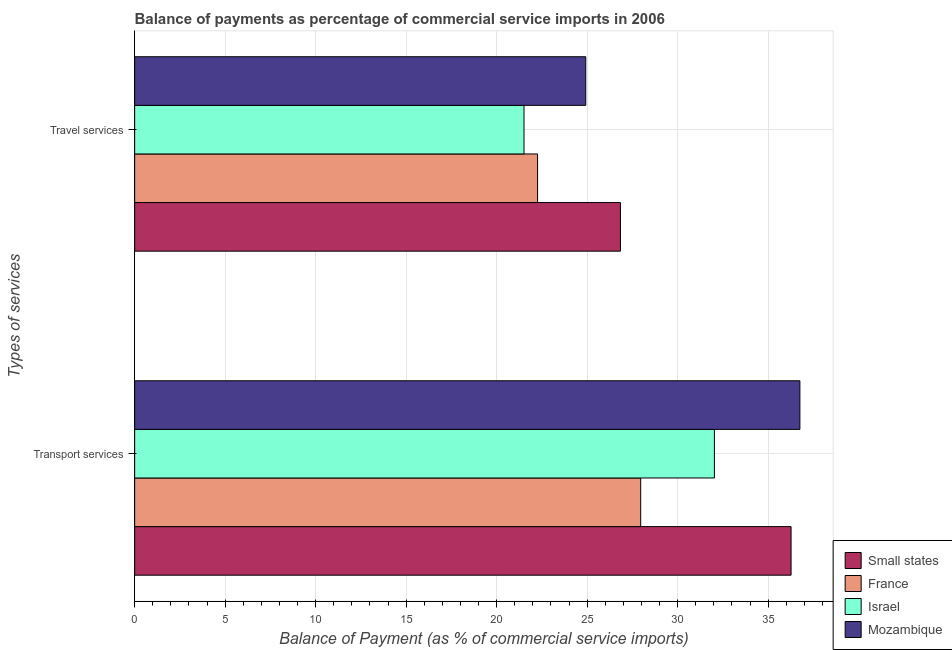How many different coloured bars are there?
Make the answer very short. 4. Are the number of bars per tick equal to the number of legend labels?
Your response must be concise. Yes. How many bars are there on the 1st tick from the bottom?
Provide a succinct answer. 4. What is the label of the 2nd group of bars from the top?
Offer a terse response. Transport services. What is the balance of payments of travel services in Small states?
Your response must be concise. 26.84. Across all countries, what is the maximum balance of payments of travel services?
Offer a terse response. 26.84. Across all countries, what is the minimum balance of payments of travel services?
Give a very brief answer. 21.51. In which country was the balance of payments of transport services maximum?
Keep it short and to the point. Mozambique. In which country was the balance of payments of travel services minimum?
Keep it short and to the point. Israel. What is the total balance of payments of transport services in the graph?
Provide a short and direct response. 133.02. What is the difference between the balance of payments of transport services in Mozambique and that in Israel?
Give a very brief answer. 4.72. What is the difference between the balance of payments of transport services in France and the balance of payments of travel services in Small states?
Give a very brief answer. 1.12. What is the average balance of payments of transport services per country?
Ensure brevity in your answer.  33.25. What is the difference between the balance of payments of travel services and balance of payments of transport services in Small states?
Offer a very short reply. -9.43. In how many countries, is the balance of payments of transport services greater than 9 %?
Give a very brief answer. 4. What is the ratio of the balance of payments of transport services in Small states to that in Israel?
Ensure brevity in your answer.  1.13. In how many countries, is the balance of payments of transport services greater than the average balance of payments of transport services taken over all countries?
Provide a succinct answer. 2. What does the 4th bar from the bottom in Transport services represents?
Give a very brief answer. Mozambique. How many countries are there in the graph?
Offer a terse response. 4. What is the difference between two consecutive major ticks on the X-axis?
Provide a succinct answer. 5. Does the graph contain any zero values?
Your answer should be very brief. No. How many legend labels are there?
Give a very brief answer. 4. How are the legend labels stacked?
Your response must be concise. Vertical. What is the title of the graph?
Your response must be concise. Balance of payments as percentage of commercial service imports in 2006. What is the label or title of the X-axis?
Provide a short and direct response. Balance of Payment (as % of commercial service imports). What is the label or title of the Y-axis?
Provide a short and direct response. Types of services. What is the Balance of Payment (as % of commercial service imports) of Small states in Transport services?
Make the answer very short. 36.27. What is the Balance of Payment (as % of commercial service imports) of France in Transport services?
Your response must be concise. 27.96. What is the Balance of Payment (as % of commercial service imports) of Israel in Transport services?
Your answer should be compact. 32.03. What is the Balance of Payment (as % of commercial service imports) in Mozambique in Transport services?
Ensure brevity in your answer.  36.76. What is the Balance of Payment (as % of commercial service imports) in Small states in Travel services?
Offer a terse response. 26.84. What is the Balance of Payment (as % of commercial service imports) in France in Travel services?
Offer a very short reply. 22.26. What is the Balance of Payment (as % of commercial service imports) in Israel in Travel services?
Keep it short and to the point. 21.51. What is the Balance of Payment (as % of commercial service imports) in Mozambique in Travel services?
Make the answer very short. 24.93. Across all Types of services, what is the maximum Balance of Payment (as % of commercial service imports) in Small states?
Your response must be concise. 36.27. Across all Types of services, what is the maximum Balance of Payment (as % of commercial service imports) in France?
Your answer should be compact. 27.96. Across all Types of services, what is the maximum Balance of Payment (as % of commercial service imports) of Israel?
Give a very brief answer. 32.03. Across all Types of services, what is the maximum Balance of Payment (as % of commercial service imports) of Mozambique?
Offer a terse response. 36.76. Across all Types of services, what is the minimum Balance of Payment (as % of commercial service imports) in Small states?
Provide a succinct answer. 26.84. Across all Types of services, what is the minimum Balance of Payment (as % of commercial service imports) in France?
Keep it short and to the point. 22.26. Across all Types of services, what is the minimum Balance of Payment (as % of commercial service imports) of Israel?
Make the answer very short. 21.51. Across all Types of services, what is the minimum Balance of Payment (as % of commercial service imports) of Mozambique?
Make the answer very short. 24.93. What is the total Balance of Payment (as % of commercial service imports) in Small states in the graph?
Offer a very short reply. 63.11. What is the total Balance of Payment (as % of commercial service imports) of France in the graph?
Your answer should be compact. 50.22. What is the total Balance of Payment (as % of commercial service imports) of Israel in the graph?
Provide a short and direct response. 53.55. What is the total Balance of Payment (as % of commercial service imports) of Mozambique in the graph?
Keep it short and to the point. 61.68. What is the difference between the Balance of Payment (as % of commercial service imports) of Small states in Transport services and that in Travel services?
Give a very brief answer. 9.43. What is the difference between the Balance of Payment (as % of commercial service imports) in France in Transport services and that in Travel services?
Give a very brief answer. 5.7. What is the difference between the Balance of Payment (as % of commercial service imports) of Israel in Transport services and that in Travel services?
Provide a succinct answer. 10.52. What is the difference between the Balance of Payment (as % of commercial service imports) in Mozambique in Transport services and that in Travel services?
Ensure brevity in your answer.  11.83. What is the difference between the Balance of Payment (as % of commercial service imports) in Small states in Transport services and the Balance of Payment (as % of commercial service imports) in France in Travel services?
Your response must be concise. 14.01. What is the difference between the Balance of Payment (as % of commercial service imports) of Small states in Transport services and the Balance of Payment (as % of commercial service imports) of Israel in Travel services?
Your answer should be compact. 14.76. What is the difference between the Balance of Payment (as % of commercial service imports) of Small states in Transport services and the Balance of Payment (as % of commercial service imports) of Mozambique in Travel services?
Give a very brief answer. 11.34. What is the difference between the Balance of Payment (as % of commercial service imports) of France in Transport services and the Balance of Payment (as % of commercial service imports) of Israel in Travel services?
Provide a succinct answer. 6.45. What is the difference between the Balance of Payment (as % of commercial service imports) in France in Transport services and the Balance of Payment (as % of commercial service imports) in Mozambique in Travel services?
Your answer should be compact. 3.04. What is the difference between the Balance of Payment (as % of commercial service imports) of Israel in Transport services and the Balance of Payment (as % of commercial service imports) of Mozambique in Travel services?
Offer a very short reply. 7.11. What is the average Balance of Payment (as % of commercial service imports) of Small states per Types of services?
Ensure brevity in your answer.  31.56. What is the average Balance of Payment (as % of commercial service imports) in France per Types of services?
Ensure brevity in your answer.  25.11. What is the average Balance of Payment (as % of commercial service imports) in Israel per Types of services?
Keep it short and to the point. 26.77. What is the average Balance of Payment (as % of commercial service imports) in Mozambique per Types of services?
Provide a succinct answer. 30.84. What is the difference between the Balance of Payment (as % of commercial service imports) in Small states and Balance of Payment (as % of commercial service imports) in France in Transport services?
Keep it short and to the point. 8.31. What is the difference between the Balance of Payment (as % of commercial service imports) of Small states and Balance of Payment (as % of commercial service imports) of Israel in Transport services?
Ensure brevity in your answer.  4.24. What is the difference between the Balance of Payment (as % of commercial service imports) in Small states and Balance of Payment (as % of commercial service imports) in Mozambique in Transport services?
Your response must be concise. -0.49. What is the difference between the Balance of Payment (as % of commercial service imports) of France and Balance of Payment (as % of commercial service imports) of Israel in Transport services?
Provide a short and direct response. -4.07. What is the difference between the Balance of Payment (as % of commercial service imports) of France and Balance of Payment (as % of commercial service imports) of Mozambique in Transport services?
Provide a succinct answer. -8.8. What is the difference between the Balance of Payment (as % of commercial service imports) of Israel and Balance of Payment (as % of commercial service imports) of Mozambique in Transport services?
Offer a terse response. -4.72. What is the difference between the Balance of Payment (as % of commercial service imports) of Small states and Balance of Payment (as % of commercial service imports) of France in Travel services?
Make the answer very short. 4.58. What is the difference between the Balance of Payment (as % of commercial service imports) in Small states and Balance of Payment (as % of commercial service imports) in Israel in Travel services?
Offer a terse response. 5.33. What is the difference between the Balance of Payment (as % of commercial service imports) of Small states and Balance of Payment (as % of commercial service imports) of Mozambique in Travel services?
Your answer should be very brief. 1.92. What is the difference between the Balance of Payment (as % of commercial service imports) in France and Balance of Payment (as % of commercial service imports) in Israel in Travel services?
Make the answer very short. 0.75. What is the difference between the Balance of Payment (as % of commercial service imports) of France and Balance of Payment (as % of commercial service imports) of Mozambique in Travel services?
Your response must be concise. -2.66. What is the difference between the Balance of Payment (as % of commercial service imports) in Israel and Balance of Payment (as % of commercial service imports) in Mozambique in Travel services?
Your answer should be very brief. -3.41. What is the ratio of the Balance of Payment (as % of commercial service imports) of Small states in Transport services to that in Travel services?
Provide a short and direct response. 1.35. What is the ratio of the Balance of Payment (as % of commercial service imports) in France in Transport services to that in Travel services?
Offer a very short reply. 1.26. What is the ratio of the Balance of Payment (as % of commercial service imports) in Israel in Transport services to that in Travel services?
Your response must be concise. 1.49. What is the ratio of the Balance of Payment (as % of commercial service imports) of Mozambique in Transport services to that in Travel services?
Ensure brevity in your answer.  1.47. What is the difference between the highest and the second highest Balance of Payment (as % of commercial service imports) of Small states?
Make the answer very short. 9.43. What is the difference between the highest and the second highest Balance of Payment (as % of commercial service imports) in France?
Make the answer very short. 5.7. What is the difference between the highest and the second highest Balance of Payment (as % of commercial service imports) of Israel?
Provide a succinct answer. 10.52. What is the difference between the highest and the second highest Balance of Payment (as % of commercial service imports) in Mozambique?
Keep it short and to the point. 11.83. What is the difference between the highest and the lowest Balance of Payment (as % of commercial service imports) of Small states?
Your answer should be compact. 9.43. What is the difference between the highest and the lowest Balance of Payment (as % of commercial service imports) in France?
Keep it short and to the point. 5.7. What is the difference between the highest and the lowest Balance of Payment (as % of commercial service imports) in Israel?
Your response must be concise. 10.52. What is the difference between the highest and the lowest Balance of Payment (as % of commercial service imports) in Mozambique?
Give a very brief answer. 11.83. 